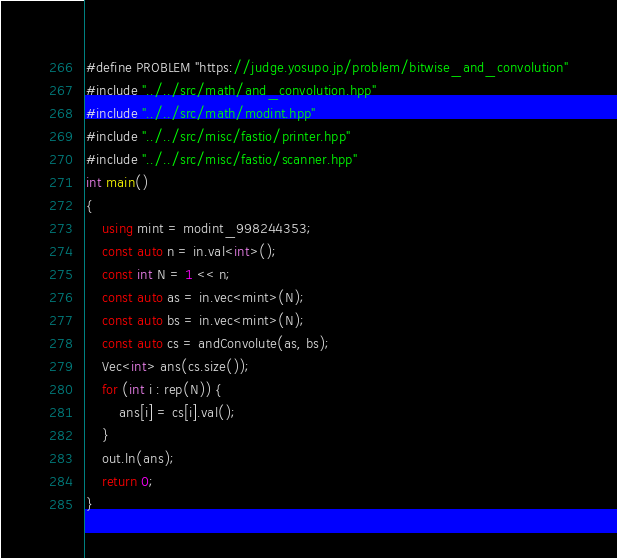Convert code to text. <code><loc_0><loc_0><loc_500><loc_500><_C++_>#define PROBLEM "https://judge.yosupo.jp/problem/bitwise_and_convolution"
#include "../../src/math/and_convolution.hpp"
#include "../../src/math/modint.hpp"
#include "../../src/misc/fastio/printer.hpp"
#include "../../src/misc/fastio/scanner.hpp"
int main()
{
    using mint = modint_998244353;
    const auto n = in.val<int>();
    const int N = 1 << n;
    const auto as = in.vec<mint>(N);
    const auto bs = in.vec<mint>(N);
    const auto cs = andConvolute(as, bs);
    Vec<int> ans(cs.size());
    for (int i : rep(N)) {
        ans[i] = cs[i].val();
    }
    out.ln(ans);
    return 0;
}
</code> 